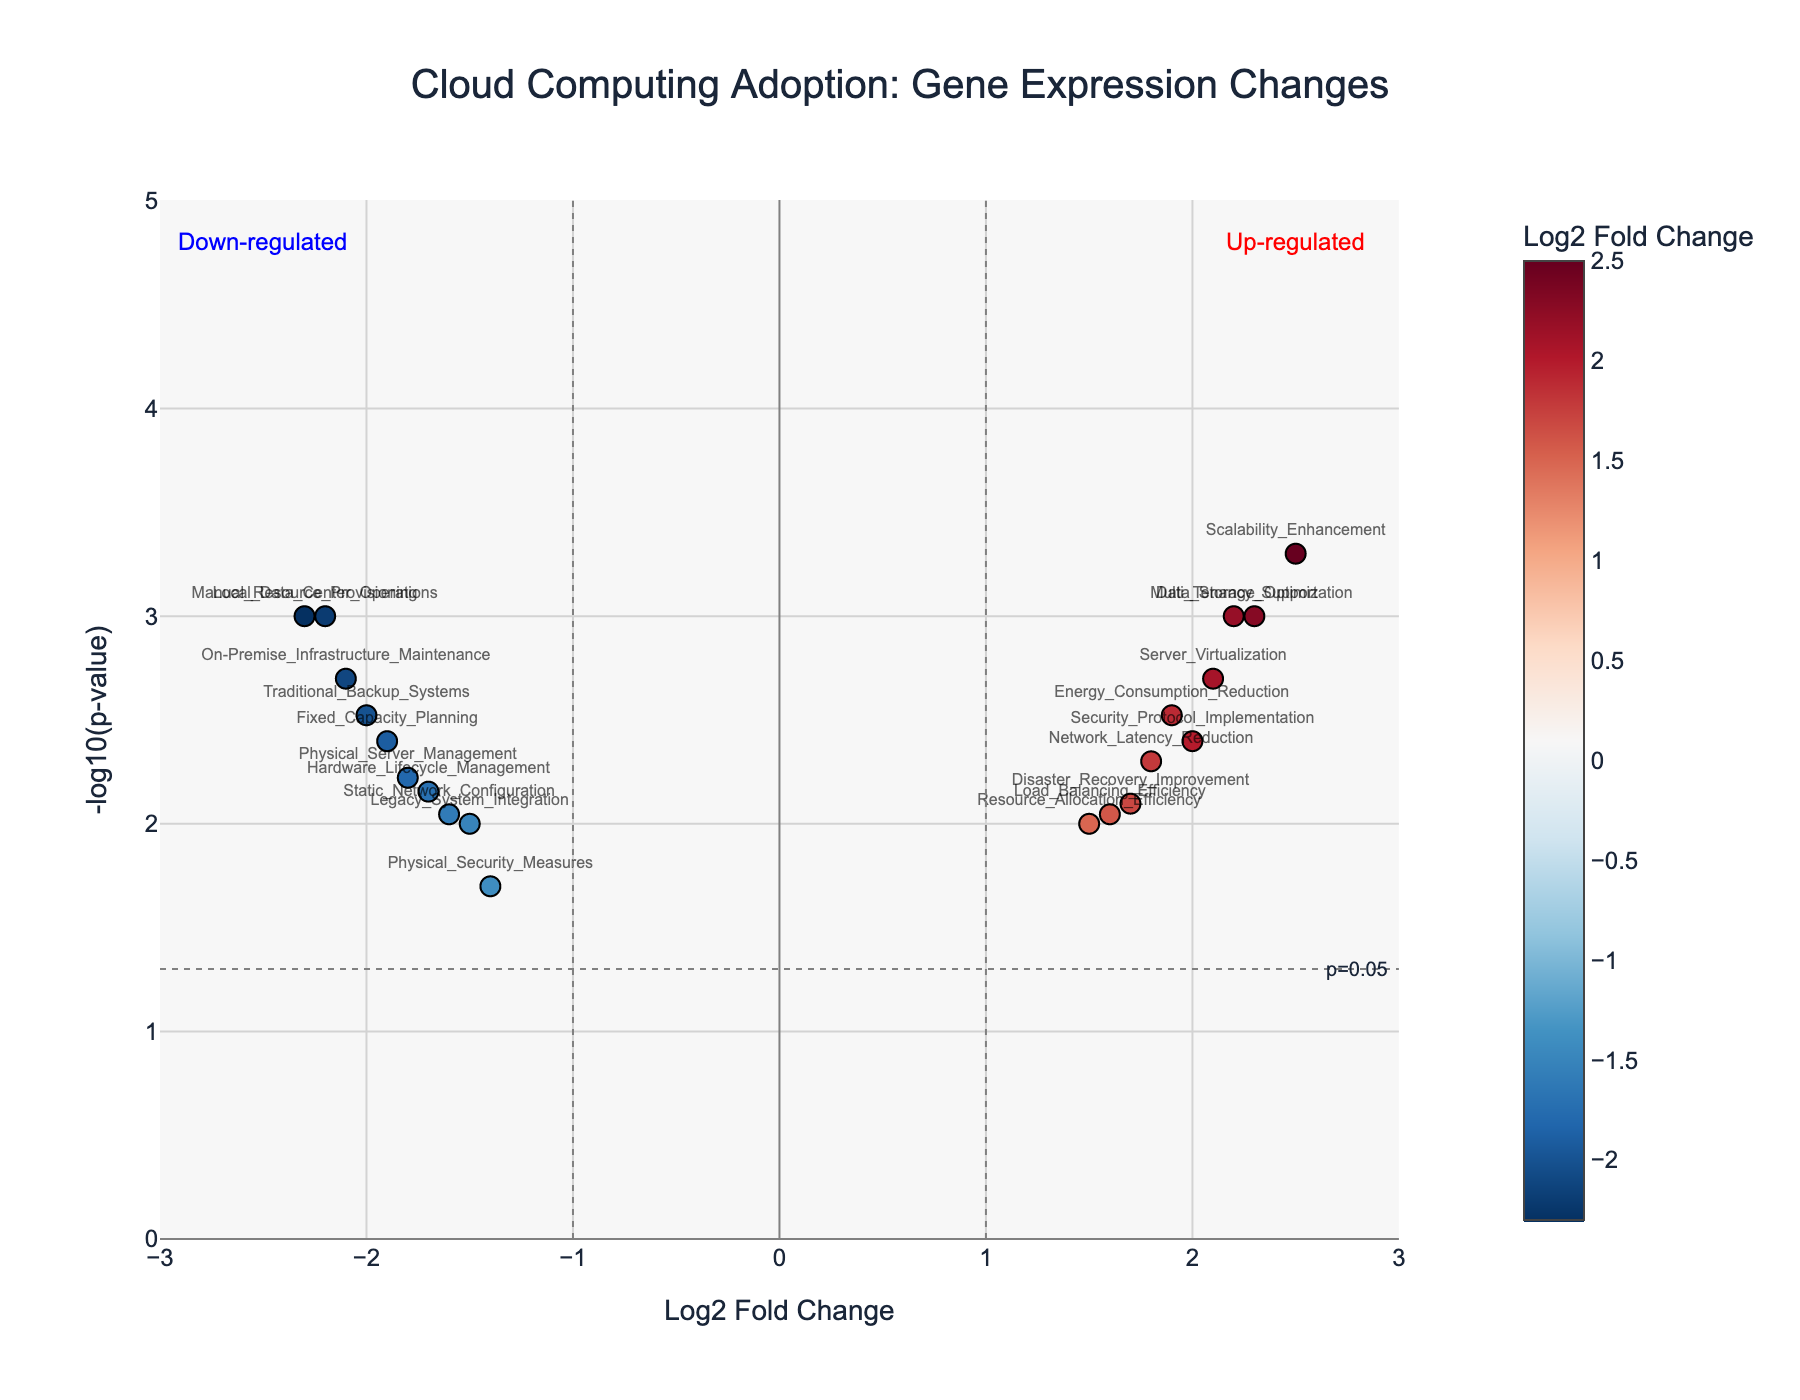What's the title of the figure? The title is displayed at the top of the plot.
Answer: Cloud Computing Adoption: Gene Expression Changes What is represented on the x-axis? The x-axis label provides this information.
Answer: Log2 Fold Change What does the y-axis represent? The y-axis label gives a description of what is measured.
Answer: -log10(p-value) How many data points are represented on the plot? Each point represents a gene, and we can count the total number of points.
Answer: 19 Which gene process has the highest Log2 Fold Change value? By identifying the right-most point on the x-axis, we can see the gene process with the highest Log2 Fold Change.
Answer: Scalability_Enhancement Which gene process has the lowest Log2 Fold Change value? By identifying the left-most point on the x-axis, we can see the gene process with the lowest Log2 Fold Change.
Answer: Manual_Resource_Provisioning Which gene process has the smallest p-value (most significant)? The gene process with the smallest p-value will appear as the highest point on the y-axis because the y-axis is -log10(p-value).
Answer: Scalability_Enhancement How many up-regulated gene processes are significantly affected (p-value < 0.05)? Count the number of points on the right side of the x-axis threshold line (Log2 Fold Change > 1) that are above the horizontal line indicating p-value = 0.05.
Answer: 8 Which gene processes are significantly down-regulated (p-value < 0.05)? Look for points on the left side of the x-axis threshold line (Log2 Fold Change < -1) that are above the horizontal line indicating p-value = 0.05.
Answer: On-Premise_Infrastructure_Maintenance, Manual_Resource_Provisioning, Local_Data_Center_Operations, Physical_Server_Management, Traditional_Backup_Systems, Fixed_Capacity_Planning, and Static_Network_Configuration What value on the y-axis corresponds to a p-value of 0.05? The horizontal line for p-value = 0.05 marks this value on the y-axis.
Answer: -log10(0.05) which equals to 1.301 